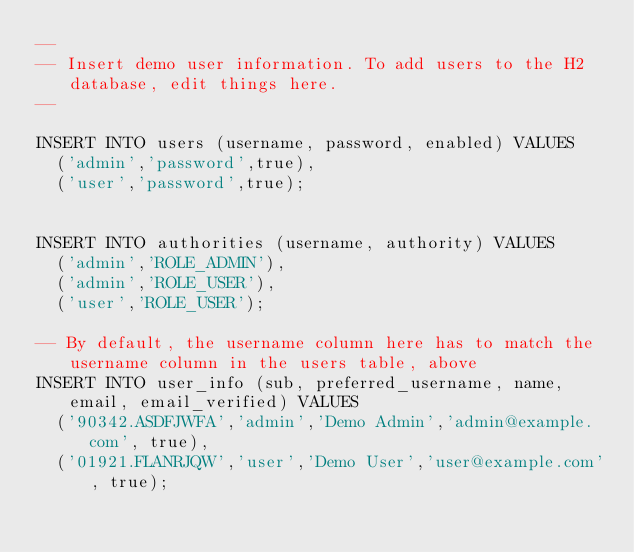<code> <loc_0><loc_0><loc_500><loc_500><_SQL_>--
-- Insert demo user information. To add users to the H2 database, edit things here.
-- 

INSERT INTO users (username, password, enabled) VALUES
  ('admin','password',true),
  ('user','password',true);


INSERT INTO authorities (username, authority) VALUES
  ('admin','ROLE_ADMIN'),
  ('admin','ROLE_USER'),
  ('user','ROLE_USER');
    
-- By default, the username column here has to match the username column in the users table, above
INSERT INTO user_info (sub, preferred_username, name, email, email_verified) VALUES
  ('90342.ASDFJWFA','admin','Demo Admin','admin@example.com', true),
  ('01921.FLANRJQW','user','Demo User','user@example.com', true);</code> 